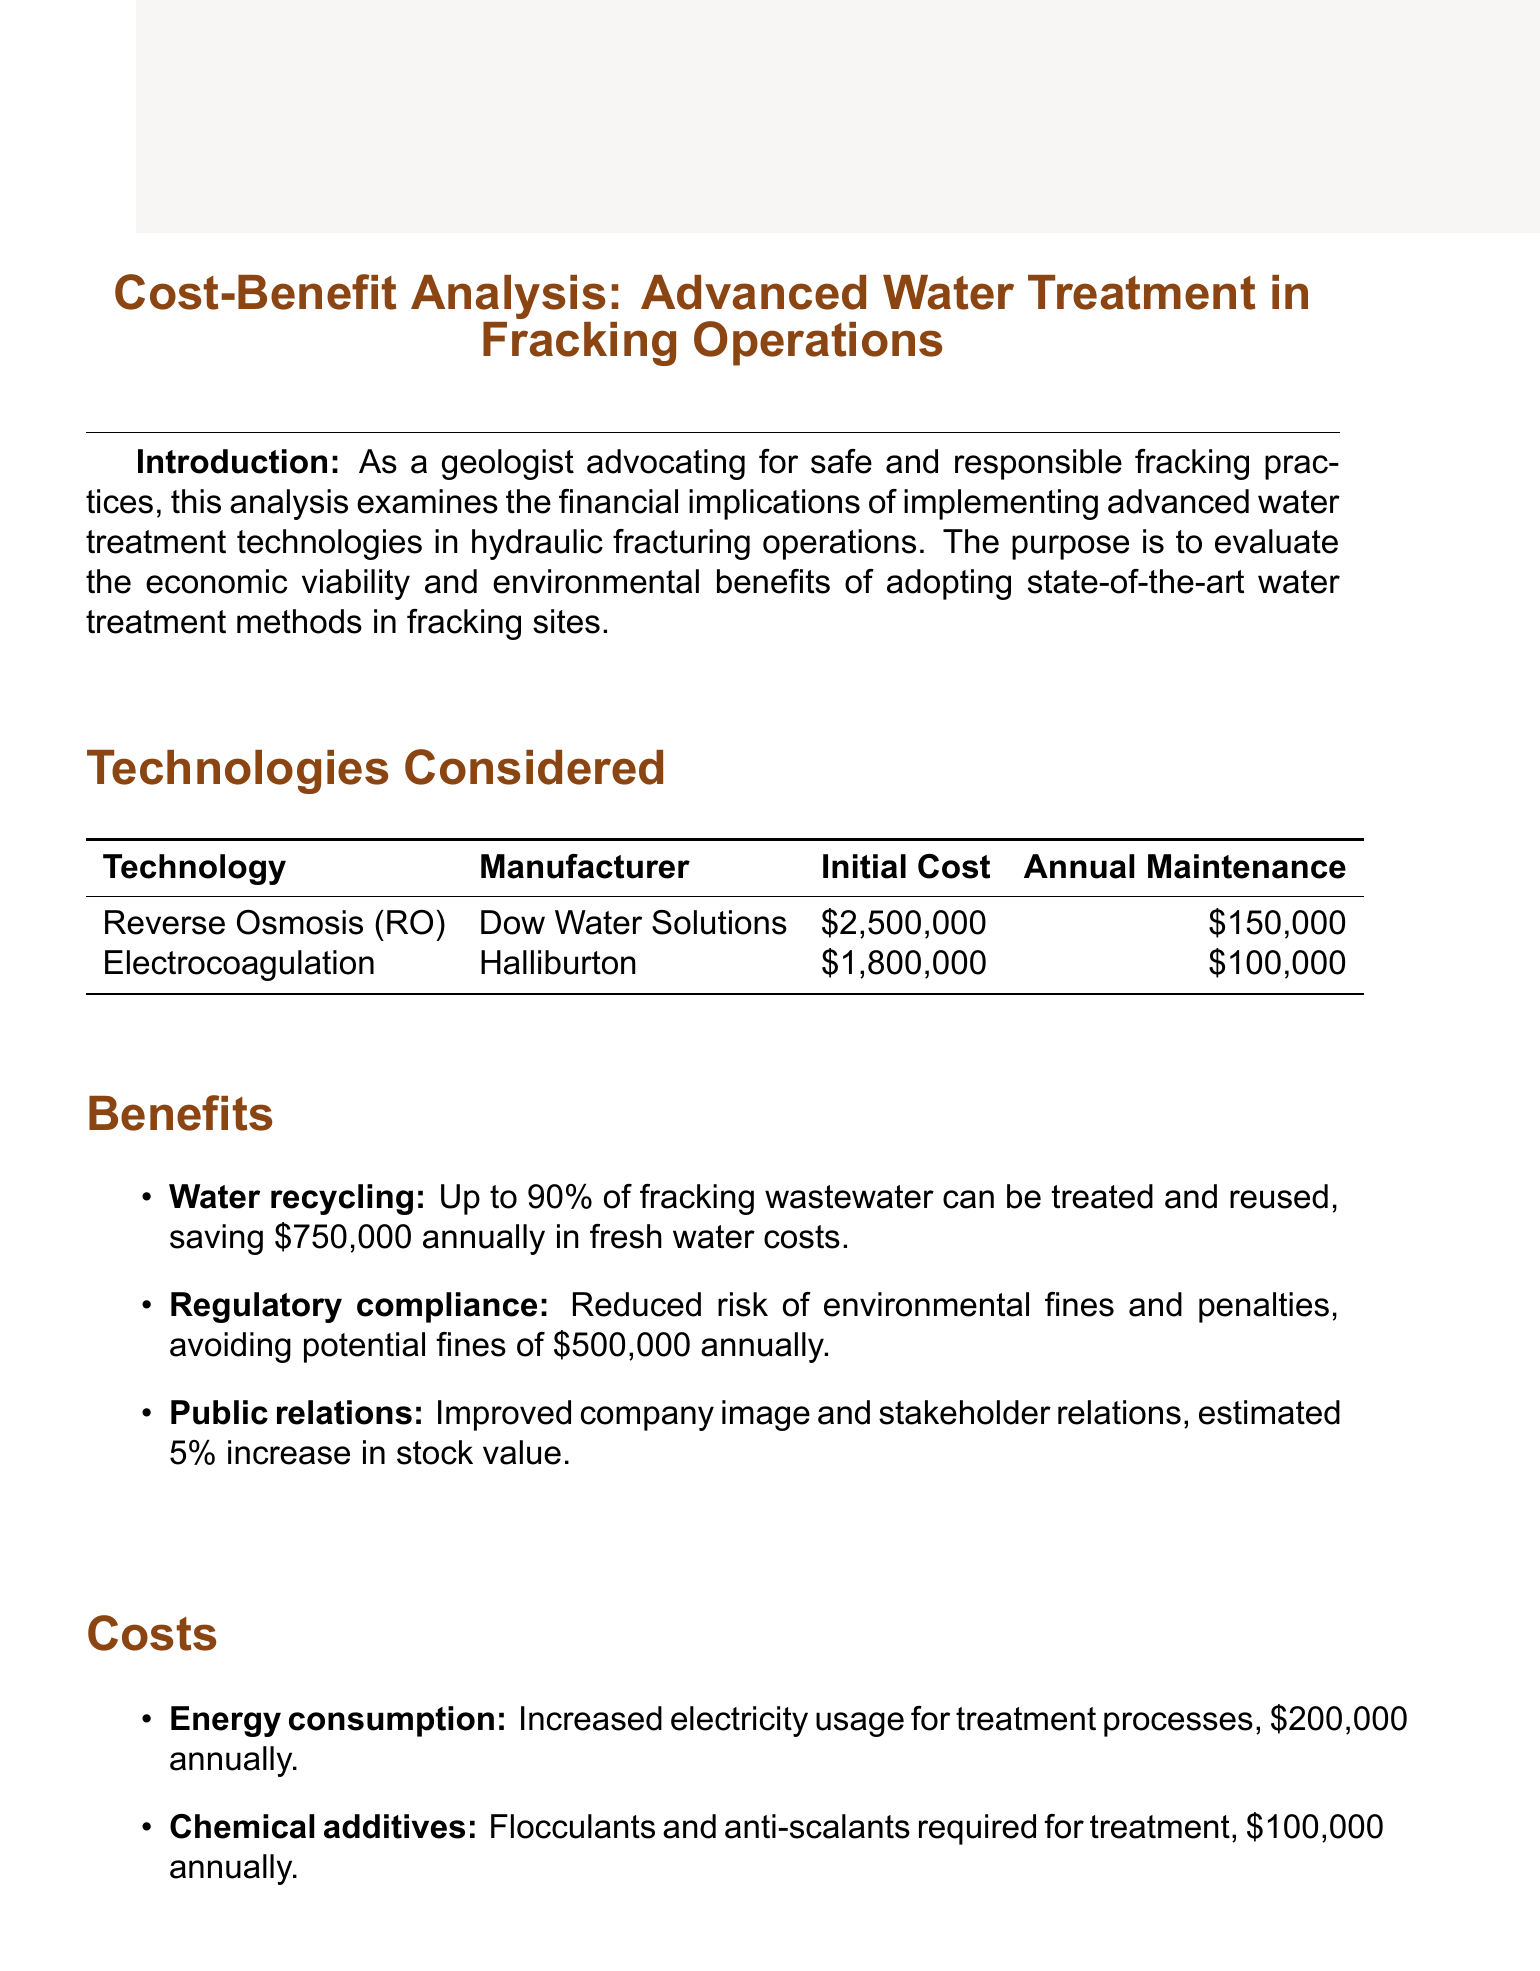What is the title of the report? The title is stated at the beginning of the document.
Answer: Cost-Benefit Analysis: Advanced Water Treatment in Fracking Operations What is the initial cost of Reverse Osmosis technology? The initial cost is provided in the "Technologies Considered" section.
Answer: $2,500,000 What is the annual savings from water recycling? The annual savings from water recycling is mentioned under the "Benefits" section.
Answer: $750,000 in fresh water costs What is the payback period for the investment? The payback period is located in the "ROI Analysis" section.
Answer: 3.2 years Which technology is recommended for implementation? The recommendation is found in the "Conclusion" section.
Answer: Reverse Osmosis technology What is the annual cost of chemical additives? The annual cost is stated under the "Costs" section of the document.
Answer: $100,000 What is the internal rate of return for the project? The internal rate of return is detailed in the "ROI Analysis" section.
Answer: 22% What is the total annual cost of energy consumption and chemical additives combined? This requires adding both annual costs listed under the "Costs" section.
Answer: $300,000 What is the estimated percentage increase in stock value due to public relations benefits? The percentage increase is mentioned in the "Benefits" section.
Answer: 5% increase in stock value 